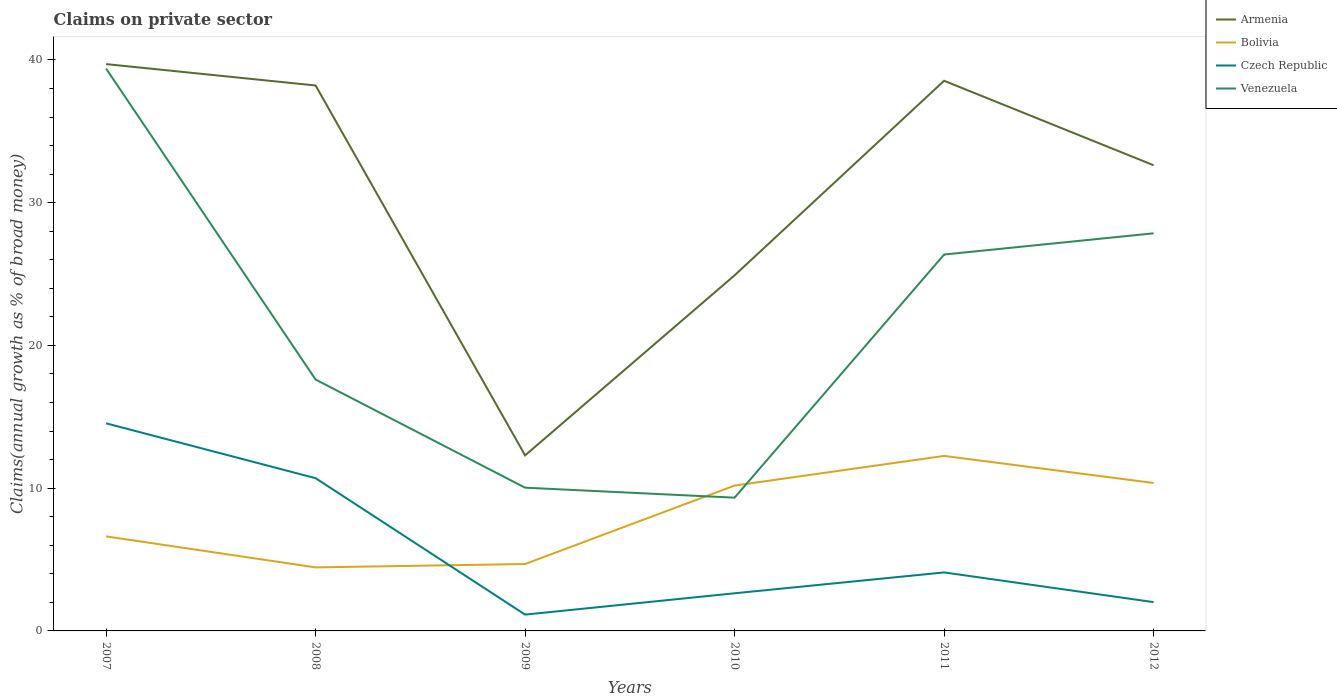Does the line corresponding to Armenia intersect with the line corresponding to Czech Republic?
Keep it short and to the point. No. Across all years, what is the maximum percentage of broad money claimed on private sector in Czech Republic?
Ensure brevity in your answer.  1.14. In which year was the percentage of broad money claimed on private sector in Czech Republic maximum?
Keep it short and to the point. 2009. What is the total percentage of broad money claimed on private sector in Armenia in the graph?
Provide a short and direct response. -7.71. What is the difference between the highest and the second highest percentage of broad money claimed on private sector in Bolivia?
Make the answer very short. 7.81. Are the values on the major ticks of Y-axis written in scientific E-notation?
Your answer should be very brief. No. Where does the legend appear in the graph?
Ensure brevity in your answer.  Top right. How many legend labels are there?
Your answer should be very brief. 4. How are the legend labels stacked?
Your answer should be very brief. Vertical. What is the title of the graph?
Offer a very short reply. Claims on private sector. What is the label or title of the X-axis?
Give a very brief answer. Years. What is the label or title of the Y-axis?
Provide a short and direct response. Claims(annual growth as % of broad money). What is the Claims(annual growth as % of broad money) of Armenia in 2007?
Your answer should be compact. 39.71. What is the Claims(annual growth as % of broad money) of Bolivia in 2007?
Ensure brevity in your answer.  6.62. What is the Claims(annual growth as % of broad money) in Czech Republic in 2007?
Give a very brief answer. 14.54. What is the Claims(annual growth as % of broad money) in Venezuela in 2007?
Keep it short and to the point. 39.39. What is the Claims(annual growth as % of broad money) of Armenia in 2008?
Your response must be concise. 38.21. What is the Claims(annual growth as % of broad money) in Bolivia in 2008?
Your response must be concise. 4.45. What is the Claims(annual growth as % of broad money) in Czech Republic in 2008?
Your answer should be very brief. 10.7. What is the Claims(annual growth as % of broad money) of Venezuela in 2008?
Provide a short and direct response. 17.61. What is the Claims(annual growth as % of broad money) of Armenia in 2009?
Give a very brief answer. 12.3. What is the Claims(annual growth as % of broad money) of Bolivia in 2009?
Give a very brief answer. 4.69. What is the Claims(annual growth as % of broad money) of Czech Republic in 2009?
Offer a terse response. 1.14. What is the Claims(annual growth as % of broad money) of Venezuela in 2009?
Make the answer very short. 10.03. What is the Claims(annual growth as % of broad money) in Armenia in 2010?
Offer a very short reply. 24.91. What is the Claims(annual growth as % of broad money) in Bolivia in 2010?
Give a very brief answer. 10.18. What is the Claims(annual growth as % of broad money) of Czech Republic in 2010?
Provide a short and direct response. 2.64. What is the Claims(annual growth as % of broad money) in Venezuela in 2010?
Ensure brevity in your answer.  9.33. What is the Claims(annual growth as % of broad money) of Armenia in 2011?
Keep it short and to the point. 38.54. What is the Claims(annual growth as % of broad money) in Bolivia in 2011?
Your answer should be very brief. 12.26. What is the Claims(annual growth as % of broad money) of Czech Republic in 2011?
Your answer should be compact. 4.1. What is the Claims(annual growth as % of broad money) of Venezuela in 2011?
Offer a very short reply. 26.37. What is the Claims(annual growth as % of broad money) in Armenia in 2012?
Give a very brief answer. 32.62. What is the Claims(annual growth as % of broad money) in Bolivia in 2012?
Your answer should be compact. 10.36. What is the Claims(annual growth as % of broad money) in Czech Republic in 2012?
Provide a succinct answer. 2.02. What is the Claims(annual growth as % of broad money) of Venezuela in 2012?
Your answer should be very brief. 27.85. Across all years, what is the maximum Claims(annual growth as % of broad money) of Armenia?
Offer a very short reply. 39.71. Across all years, what is the maximum Claims(annual growth as % of broad money) in Bolivia?
Ensure brevity in your answer.  12.26. Across all years, what is the maximum Claims(annual growth as % of broad money) in Czech Republic?
Ensure brevity in your answer.  14.54. Across all years, what is the maximum Claims(annual growth as % of broad money) of Venezuela?
Keep it short and to the point. 39.39. Across all years, what is the minimum Claims(annual growth as % of broad money) in Armenia?
Provide a succinct answer. 12.3. Across all years, what is the minimum Claims(annual growth as % of broad money) of Bolivia?
Make the answer very short. 4.45. Across all years, what is the minimum Claims(annual growth as % of broad money) in Czech Republic?
Your answer should be compact. 1.14. Across all years, what is the minimum Claims(annual growth as % of broad money) of Venezuela?
Ensure brevity in your answer.  9.33. What is the total Claims(annual growth as % of broad money) in Armenia in the graph?
Offer a terse response. 186.28. What is the total Claims(annual growth as % of broad money) of Bolivia in the graph?
Provide a succinct answer. 48.56. What is the total Claims(annual growth as % of broad money) in Czech Republic in the graph?
Keep it short and to the point. 35.14. What is the total Claims(annual growth as % of broad money) of Venezuela in the graph?
Give a very brief answer. 130.59. What is the difference between the Claims(annual growth as % of broad money) in Armenia in 2007 and that in 2008?
Offer a very short reply. 1.5. What is the difference between the Claims(annual growth as % of broad money) in Bolivia in 2007 and that in 2008?
Offer a very short reply. 2.17. What is the difference between the Claims(annual growth as % of broad money) of Czech Republic in 2007 and that in 2008?
Make the answer very short. 3.84. What is the difference between the Claims(annual growth as % of broad money) of Venezuela in 2007 and that in 2008?
Your answer should be compact. 21.78. What is the difference between the Claims(annual growth as % of broad money) in Armenia in 2007 and that in 2009?
Your answer should be very brief. 27.41. What is the difference between the Claims(annual growth as % of broad money) of Bolivia in 2007 and that in 2009?
Keep it short and to the point. 1.94. What is the difference between the Claims(annual growth as % of broad money) of Czech Republic in 2007 and that in 2009?
Your answer should be very brief. 13.4. What is the difference between the Claims(annual growth as % of broad money) in Venezuela in 2007 and that in 2009?
Offer a terse response. 29.36. What is the difference between the Claims(annual growth as % of broad money) in Armenia in 2007 and that in 2010?
Make the answer very short. 14.8. What is the difference between the Claims(annual growth as % of broad money) in Bolivia in 2007 and that in 2010?
Keep it short and to the point. -3.56. What is the difference between the Claims(annual growth as % of broad money) in Czech Republic in 2007 and that in 2010?
Provide a short and direct response. 11.91. What is the difference between the Claims(annual growth as % of broad money) in Venezuela in 2007 and that in 2010?
Provide a short and direct response. 30.06. What is the difference between the Claims(annual growth as % of broad money) in Armenia in 2007 and that in 2011?
Your response must be concise. 1.17. What is the difference between the Claims(annual growth as % of broad money) in Bolivia in 2007 and that in 2011?
Make the answer very short. -5.64. What is the difference between the Claims(annual growth as % of broad money) of Czech Republic in 2007 and that in 2011?
Your answer should be compact. 10.44. What is the difference between the Claims(annual growth as % of broad money) in Venezuela in 2007 and that in 2011?
Provide a short and direct response. 13.03. What is the difference between the Claims(annual growth as % of broad money) of Armenia in 2007 and that in 2012?
Your response must be concise. 7.09. What is the difference between the Claims(annual growth as % of broad money) in Bolivia in 2007 and that in 2012?
Provide a succinct answer. -3.74. What is the difference between the Claims(annual growth as % of broad money) in Czech Republic in 2007 and that in 2012?
Keep it short and to the point. 12.52. What is the difference between the Claims(annual growth as % of broad money) of Venezuela in 2007 and that in 2012?
Your answer should be very brief. 11.54. What is the difference between the Claims(annual growth as % of broad money) in Armenia in 2008 and that in 2009?
Make the answer very short. 25.91. What is the difference between the Claims(annual growth as % of broad money) of Bolivia in 2008 and that in 2009?
Offer a very short reply. -0.24. What is the difference between the Claims(annual growth as % of broad money) of Czech Republic in 2008 and that in 2009?
Ensure brevity in your answer.  9.56. What is the difference between the Claims(annual growth as % of broad money) in Venezuela in 2008 and that in 2009?
Your answer should be compact. 7.58. What is the difference between the Claims(annual growth as % of broad money) of Armenia in 2008 and that in 2010?
Keep it short and to the point. 13.3. What is the difference between the Claims(annual growth as % of broad money) in Bolivia in 2008 and that in 2010?
Your answer should be very brief. -5.73. What is the difference between the Claims(annual growth as % of broad money) of Czech Republic in 2008 and that in 2010?
Provide a short and direct response. 8.06. What is the difference between the Claims(annual growth as % of broad money) of Venezuela in 2008 and that in 2010?
Ensure brevity in your answer.  8.27. What is the difference between the Claims(annual growth as % of broad money) in Armenia in 2008 and that in 2011?
Your answer should be compact. -0.33. What is the difference between the Claims(annual growth as % of broad money) of Bolivia in 2008 and that in 2011?
Your answer should be compact. -7.81. What is the difference between the Claims(annual growth as % of broad money) of Czech Republic in 2008 and that in 2011?
Your answer should be compact. 6.6. What is the difference between the Claims(annual growth as % of broad money) in Venezuela in 2008 and that in 2011?
Provide a succinct answer. -8.76. What is the difference between the Claims(annual growth as % of broad money) of Armenia in 2008 and that in 2012?
Your answer should be very brief. 5.59. What is the difference between the Claims(annual growth as % of broad money) of Bolivia in 2008 and that in 2012?
Your answer should be compact. -5.91. What is the difference between the Claims(annual growth as % of broad money) of Czech Republic in 2008 and that in 2012?
Keep it short and to the point. 8.68. What is the difference between the Claims(annual growth as % of broad money) of Venezuela in 2008 and that in 2012?
Make the answer very short. -10.24. What is the difference between the Claims(annual growth as % of broad money) of Armenia in 2009 and that in 2010?
Make the answer very short. -12.61. What is the difference between the Claims(annual growth as % of broad money) in Bolivia in 2009 and that in 2010?
Your response must be concise. -5.5. What is the difference between the Claims(annual growth as % of broad money) of Czech Republic in 2009 and that in 2010?
Offer a terse response. -1.49. What is the difference between the Claims(annual growth as % of broad money) of Venezuela in 2009 and that in 2010?
Your answer should be very brief. 0.7. What is the difference between the Claims(annual growth as % of broad money) of Armenia in 2009 and that in 2011?
Give a very brief answer. -26.24. What is the difference between the Claims(annual growth as % of broad money) in Bolivia in 2009 and that in 2011?
Your answer should be compact. -7.57. What is the difference between the Claims(annual growth as % of broad money) in Czech Republic in 2009 and that in 2011?
Your response must be concise. -2.95. What is the difference between the Claims(annual growth as % of broad money) of Venezuela in 2009 and that in 2011?
Offer a very short reply. -16.33. What is the difference between the Claims(annual growth as % of broad money) of Armenia in 2009 and that in 2012?
Your response must be concise. -20.32. What is the difference between the Claims(annual growth as % of broad money) of Bolivia in 2009 and that in 2012?
Provide a short and direct response. -5.68. What is the difference between the Claims(annual growth as % of broad money) of Czech Republic in 2009 and that in 2012?
Make the answer very short. -0.88. What is the difference between the Claims(annual growth as % of broad money) in Venezuela in 2009 and that in 2012?
Give a very brief answer. -17.82. What is the difference between the Claims(annual growth as % of broad money) in Armenia in 2010 and that in 2011?
Make the answer very short. -13.63. What is the difference between the Claims(annual growth as % of broad money) in Bolivia in 2010 and that in 2011?
Provide a succinct answer. -2.08. What is the difference between the Claims(annual growth as % of broad money) of Czech Republic in 2010 and that in 2011?
Your response must be concise. -1.46. What is the difference between the Claims(annual growth as % of broad money) of Venezuela in 2010 and that in 2011?
Provide a short and direct response. -17.03. What is the difference between the Claims(annual growth as % of broad money) of Armenia in 2010 and that in 2012?
Keep it short and to the point. -7.71. What is the difference between the Claims(annual growth as % of broad money) of Bolivia in 2010 and that in 2012?
Provide a succinct answer. -0.18. What is the difference between the Claims(annual growth as % of broad money) of Czech Republic in 2010 and that in 2012?
Give a very brief answer. 0.62. What is the difference between the Claims(annual growth as % of broad money) in Venezuela in 2010 and that in 2012?
Provide a short and direct response. -18.52. What is the difference between the Claims(annual growth as % of broad money) in Armenia in 2011 and that in 2012?
Offer a very short reply. 5.92. What is the difference between the Claims(annual growth as % of broad money) of Bolivia in 2011 and that in 2012?
Make the answer very short. 1.9. What is the difference between the Claims(annual growth as % of broad money) of Czech Republic in 2011 and that in 2012?
Provide a succinct answer. 2.08. What is the difference between the Claims(annual growth as % of broad money) in Venezuela in 2011 and that in 2012?
Your answer should be very brief. -1.49. What is the difference between the Claims(annual growth as % of broad money) of Armenia in 2007 and the Claims(annual growth as % of broad money) of Bolivia in 2008?
Your response must be concise. 35.26. What is the difference between the Claims(annual growth as % of broad money) of Armenia in 2007 and the Claims(annual growth as % of broad money) of Czech Republic in 2008?
Keep it short and to the point. 29.01. What is the difference between the Claims(annual growth as % of broad money) in Armenia in 2007 and the Claims(annual growth as % of broad money) in Venezuela in 2008?
Offer a very short reply. 22.1. What is the difference between the Claims(annual growth as % of broad money) of Bolivia in 2007 and the Claims(annual growth as % of broad money) of Czech Republic in 2008?
Give a very brief answer. -4.08. What is the difference between the Claims(annual growth as % of broad money) in Bolivia in 2007 and the Claims(annual growth as % of broad money) in Venezuela in 2008?
Make the answer very short. -10.99. What is the difference between the Claims(annual growth as % of broad money) in Czech Republic in 2007 and the Claims(annual growth as % of broad money) in Venezuela in 2008?
Your response must be concise. -3.07. What is the difference between the Claims(annual growth as % of broad money) in Armenia in 2007 and the Claims(annual growth as % of broad money) in Bolivia in 2009?
Provide a short and direct response. 35.02. What is the difference between the Claims(annual growth as % of broad money) of Armenia in 2007 and the Claims(annual growth as % of broad money) of Czech Republic in 2009?
Make the answer very short. 38.56. What is the difference between the Claims(annual growth as % of broad money) of Armenia in 2007 and the Claims(annual growth as % of broad money) of Venezuela in 2009?
Provide a short and direct response. 29.67. What is the difference between the Claims(annual growth as % of broad money) of Bolivia in 2007 and the Claims(annual growth as % of broad money) of Czech Republic in 2009?
Keep it short and to the point. 5.48. What is the difference between the Claims(annual growth as % of broad money) in Bolivia in 2007 and the Claims(annual growth as % of broad money) in Venezuela in 2009?
Keep it short and to the point. -3.41. What is the difference between the Claims(annual growth as % of broad money) of Czech Republic in 2007 and the Claims(annual growth as % of broad money) of Venezuela in 2009?
Your answer should be very brief. 4.51. What is the difference between the Claims(annual growth as % of broad money) in Armenia in 2007 and the Claims(annual growth as % of broad money) in Bolivia in 2010?
Give a very brief answer. 29.52. What is the difference between the Claims(annual growth as % of broad money) in Armenia in 2007 and the Claims(annual growth as % of broad money) in Czech Republic in 2010?
Your answer should be very brief. 37.07. What is the difference between the Claims(annual growth as % of broad money) of Armenia in 2007 and the Claims(annual growth as % of broad money) of Venezuela in 2010?
Your answer should be very brief. 30.37. What is the difference between the Claims(annual growth as % of broad money) in Bolivia in 2007 and the Claims(annual growth as % of broad money) in Czech Republic in 2010?
Ensure brevity in your answer.  3.99. What is the difference between the Claims(annual growth as % of broad money) in Bolivia in 2007 and the Claims(annual growth as % of broad money) in Venezuela in 2010?
Keep it short and to the point. -2.71. What is the difference between the Claims(annual growth as % of broad money) of Czech Republic in 2007 and the Claims(annual growth as % of broad money) of Venezuela in 2010?
Offer a terse response. 5.21. What is the difference between the Claims(annual growth as % of broad money) in Armenia in 2007 and the Claims(annual growth as % of broad money) in Bolivia in 2011?
Your answer should be very brief. 27.45. What is the difference between the Claims(annual growth as % of broad money) in Armenia in 2007 and the Claims(annual growth as % of broad money) in Czech Republic in 2011?
Give a very brief answer. 35.61. What is the difference between the Claims(annual growth as % of broad money) of Armenia in 2007 and the Claims(annual growth as % of broad money) of Venezuela in 2011?
Make the answer very short. 13.34. What is the difference between the Claims(annual growth as % of broad money) of Bolivia in 2007 and the Claims(annual growth as % of broad money) of Czech Republic in 2011?
Your answer should be compact. 2.53. What is the difference between the Claims(annual growth as % of broad money) in Bolivia in 2007 and the Claims(annual growth as % of broad money) in Venezuela in 2011?
Provide a short and direct response. -19.74. What is the difference between the Claims(annual growth as % of broad money) in Czech Republic in 2007 and the Claims(annual growth as % of broad money) in Venezuela in 2011?
Make the answer very short. -11.82. What is the difference between the Claims(annual growth as % of broad money) of Armenia in 2007 and the Claims(annual growth as % of broad money) of Bolivia in 2012?
Give a very brief answer. 29.34. What is the difference between the Claims(annual growth as % of broad money) of Armenia in 2007 and the Claims(annual growth as % of broad money) of Czech Republic in 2012?
Offer a terse response. 37.69. What is the difference between the Claims(annual growth as % of broad money) in Armenia in 2007 and the Claims(annual growth as % of broad money) in Venezuela in 2012?
Make the answer very short. 11.85. What is the difference between the Claims(annual growth as % of broad money) in Bolivia in 2007 and the Claims(annual growth as % of broad money) in Czech Republic in 2012?
Give a very brief answer. 4.6. What is the difference between the Claims(annual growth as % of broad money) in Bolivia in 2007 and the Claims(annual growth as % of broad money) in Venezuela in 2012?
Keep it short and to the point. -21.23. What is the difference between the Claims(annual growth as % of broad money) of Czech Republic in 2007 and the Claims(annual growth as % of broad money) of Venezuela in 2012?
Keep it short and to the point. -13.31. What is the difference between the Claims(annual growth as % of broad money) in Armenia in 2008 and the Claims(annual growth as % of broad money) in Bolivia in 2009?
Provide a succinct answer. 33.52. What is the difference between the Claims(annual growth as % of broad money) in Armenia in 2008 and the Claims(annual growth as % of broad money) in Czech Republic in 2009?
Make the answer very short. 37.07. What is the difference between the Claims(annual growth as % of broad money) of Armenia in 2008 and the Claims(annual growth as % of broad money) of Venezuela in 2009?
Provide a succinct answer. 28.18. What is the difference between the Claims(annual growth as % of broad money) of Bolivia in 2008 and the Claims(annual growth as % of broad money) of Czech Republic in 2009?
Make the answer very short. 3.31. What is the difference between the Claims(annual growth as % of broad money) in Bolivia in 2008 and the Claims(annual growth as % of broad money) in Venezuela in 2009?
Your response must be concise. -5.58. What is the difference between the Claims(annual growth as % of broad money) of Czech Republic in 2008 and the Claims(annual growth as % of broad money) of Venezuela in 2009?
Your answer should be very brief. 0.67. What is the difference between the Claims(annual growth as % of broad money) in Armenia in 2008 and the Claims(annual growth as % of broad money) in Bolivia in 2010?
Your answer should be compact. 28.03. What is the difference between the Claims(annual growth as % of broad money) of Armenia in 2008 and the Claims(annual growth as % of broad money) of Czech Republic in 2010?
Your answer should be compact. 35.57. What is the difference between the Claims(annual growth as % of broad money) of Armenia in 2008 and the Claims(annual growth as % of broad money) of Venezuela in 2010?
Give a very brief answer. 28.87. What is the difference between the Claims(annual growth as % of broad money) of Bolivia in 2008 and the Claims(annual growth as % of broad money) of Czech Republic in 2010?
Offer a very short reply. 1.81. What is the difference between the Claims(annual growth as % of broad money) of Bolivia in 2008 and the Claims(annual growth as % of broad money) of Venezuela in 2010?
Provide a short and direct response. -4.88. What is the difference between the Claims(annual growth as % of broad money) of Czech Republic in 2008 and the Claims(annual growth as % of broad money) of Venezuela in 2010?
Offer a terse response. 1.37. What is the difference between the Claims(annual growth as % of broad money) of Armenia in 2008 and the Claims(annual growth as % of broad money) of Bolivia in 2011?
Provide a short and direct response. 25.95. What is the difference between the Claims(annual growth as % of broad money) in Armenia in 2008 and the Claims(annual growth as % of broad money) in Czech Republic in 2011?
Give a very brief answer. 34.11. What is the difference between the Claims(annual growth as % of broad money) of Armenia in 2008 and the Claims(annual growth as % of broad money) of Venezuela in 2011?
Provide a succinct answer. 11.84. What is the difference between the Claims(annual growth as % of broad money) in Bolivia in 2008 and the Claims(annual growth as % of broad money) in Czech Republic in 2011?
Provide a short and direct response. 0.35. What is the difference between the Claims(annual growth as % of broad money) in Bolivia in 2008 and the Claims(annual growth as % of broad money) in Venezuela in 2011?
Keep it short and to the point. -21.92. What is the difference between the Claims(annual growth as % of broad money) in Czech Republic in 2008 and the Claims(annual growth as % of broad money) in Venezuela in 2011?
Provide a succinct answer. -15.67. What is the difference between the Claims(annual growth as % of broad money) of Armenia in 2008 and the Claims(annual growth as % of broad money) of Bolivia in 2012?
Give a very brief answer. 27.85. What is the difference between the Claims(annual growth as % of broad money) in Armenia in 2008 and the Claims(annual growth as % of broad money) in Czech Republic in 2012?
Provide a succinct answer. 36.19. What is the difference between the Claims(annual growth as % of broad money) in Armenia in 2008 and the Claims(annual growth as % of broad money) in Venezuela in 2012?
Ensure brevity in your answer.  10.36. What is the difference between the Claims(annual growth as % of broad money) of Bolivia in 2008 and the Claims(annual growth as % of broad money) of Czech Republic in 2012?
Keep it short and to the point. 2.43. What is the difference between the Claims(annual growth as % of broad money) in Bolivia in 2008 and the Claims(annual growth as % of broad money) in Venezuela in 2012?
Offer a terse response. -23.4. What is the difference between the Claims(annual growth as % of broad money) of Czech Republic in 2008 and the Claims(annual growth as % of broad money) of Venezuela in 2012?
Ensure brevity in your answer.  -17.15. What is the difference between the Claims(annual growth as % of broad money) in Armenia in 2009 and the Claims(annual growth as % of broad money) in Bolivia in 2010?
Provide a succinct answer. 2.11. What is the difference between the Claims(annual growth as % of broad money) in Armenia in 2009 and the Claims(annual growth as % of broad money) in Czech Republic in 2010?
Make the answer very short. 9.66. What is the difference between the Claims(annual growth as % of broad money) in Armenia in 2009 and the Claims(annual growth as % of broad money) in Venezuela in 2010?
Ensure brevity in your answer.  2.96. What is the difference between the Claims(annual growth as % of broad money) in Bolivia in 2009 and the Claims(annual growth as % of broad money) in Czech Republic in 2010?
Your answer should be very brief. 2.05. What is the difference between the Claims(annual growth as % of broad money) in Bolivia in 2009 and the Claims(annual growth as % of broad money) in Venezuela in 2010?
Give a very brief answer. -4.65. What is the difference between the Claims(annual growth as % of broad money) in Czech Republic in 2009 and the Claims(annual growth as % of broad money) in Venezuela in 2010?
Provide a short and direct response. -8.19. What is the difference between the Claims(annual growth as % of broad money) in Armenia in 2009 and the Claims(annual growth as % of broad money) in Bolivia in 2011?
Give a very brief answer. 0.04. What is the difference between the Claims(annual growth as % of broad money) of Armenia in 2009 and the Claims(annual growth as % of broad money) of Czech Republic in 2011?
Your response must be concise. 8.2. What is the difference between the Claims(annual growth as % of broad money) in Armenia in 2009 and the Claims(annual growth as % of broad money) in Venezuela in 2011?
Make the answer very short. -14.07. What is the difference between the Claims(annual growth as % of broad money) of Bolivia in 2009 and the Claims(annual growth as % of broad money) of Czech Republic in 2011?
Ensure brevity in your answer.  0.59. What is the difference between the Claims(annual growth as % of broad money) of Bolivia in 2009 and the Claims(annual growth as % of broad money) of Venezuela in 2011?
Give a very brief answer. -21.68. What is the difference between the Claims(annual growth as % of broad money) in Czech Republic in 2009 and the Claims(annual growth as % of broad money) in Venezuela in 2011?
Provide a short and direct response. -25.22. What is the difference between the Claims(annual growth as % of broad money) in Armenia in 2009 and the Claims(annual growth as % of broad money) in Bolivia in 2012?
Your response must be concise. 1.93. What is the difference between the Claims(annual growth as % of broad money) in Armenia in 2009 and the Claims(annual growth as % of broad money) in Czech Republic in 2012?
Your answer should be very brief. 10.28. What is the difference between the Claims(annual growth as % of broad money) of Armenia in 2009 and the Claims(annual growth as % of broad money) of Venezuela in 2012?
Provide a short and direct response. -15.56. What is the difference between the Claims(annual growth as % of broad money) in Bolivia in 2009 and the Claims(annual growth as % of broad money) in Czech Republic in 2012?
Provide a short and direct response. 2.67. What is the difference between the Claims(annual growth as % of broad money) in Bolivia in 2009 and the Claims(annual growth as % of broad money) in Venezuela in 2012?
Give a very brief answer. -23.17. What is the difference between the Claims(annual growth as % of broad money) of Czech Republic in 2009 and the Claims(annual growth as % of broad money) of Venezuela in 2012?
Provide a succinct answer. -26.71. What is the difference between the Claims(annual growth as % of broad money) in Armenia in 2010 and the Claims(annual growth as % of broad money) in Bolivia in 2011?
Give a very brief answer. 12.65. What is the difference between the Claims(annual growth as % of broad money) in Armenia in 2010 and the Claims(annual growth as % of broad money) in Czech Republic in 2011?
Your answer should be very brief. 20.81. What is the difference between the Claims(annual growth as % of broad money) of Armenia in 2010 and the Claims(annual growth as % of broad money) of Venezuela in 2011?
Offer a terse response. -1.46. What is the difference between the Claims(annual growth as % of broad money) in Bolivia in 2010 and the Claims(annual growth as % of broad money) in Czech Republic in 2011?
Give a very brief answer. 6.08. What is the difference between the Claims(annual growth as % of broad money) in Bolivia in 2010 and the Claims(annual growth as % of broad money) in Venezuela in 2011?
Keep it short and to the point. -16.18. What is the difference between the Claims(annual growth as % of broad money) in Czech Republic in 2010 and the Claims(annual growth as % of broad money) in Venezuela in 2011?
Provide a succinct answer. -23.73. What is the difference between the Claims(annual growth as % of broad money) of Armenia in 2010 and the Claims(annual growth as % of broad money) of Bolivia in 2012?
Give a very brief answer. 14.55. What is the difference between the Claims(annual growth as % of broad money) in Armenia in 2010 and the Claims(annual growth as % of broad money) in Czech Republic in 2012?
Provide a succinct answer. 22.89. What is the difference between the Claims(annual growth as % of broad money) of Armenia in 2010 and the Claims(annual growth as % of broad money) of Venezuela in 2012?
Your response must be concise. -2.94. What is the difference between the Claims(annual growth as % of broad money) of Bolivia in 2010 and the Claims(annual growth as % of broad money) of Czech Republic in 2012?
Ensure brevity in your answer.  8.16. What is the difference between the Claims(annual growth as % of broad money) in Bolivia in 2010 and the Claims(annual growth as % of broad money) in Venezuela in 2012?
Offer a very short reply. -17.67. What is the difference between the Claims(annual growth as % of broad money) in Czech Republic in 2010 and the Claims(annual growth as % of broad money) in Venezuela in 2012?
Offer a terse response. -25.22. What is the difference between the Claims(annual growth as % of broad money) in Armenia in 2011 and the Claims(annual growth as % of broad money) in Bolivia in 2012?
Ensure brevity in your answer.  28.18. What is the difference between the Claims(annual growth as % of broad money) in Armenia in 2011 and the Claims(annual growth as % of broad money) in Czech Republic in 2012?
Ensure brevity in your answer.  36.52. What is the difference between the Claims(annual growth as % of broad money) in Armenia in 2011 and the Claims(annual growth as % of broad money) in Venezuela in 2012?
Make the answer very short. 10.69. What is the difference between the Claims(annual growth as % of broad money) of Bolivia in 2011 and the Claims(annual growth as % of broad money) of Czech Republic in 2012?
Your answer should be compact. 10.24. What is the difference between the Claims(annual growth as % of broad money) in Bolivia in 2011 and the Claims(annual growth as % of broad money) in Venezuela in 2012?
Your answer should be very brief. -15.59. What is the difference between the Claims(annual growth as % of broad money) in Czech Republic in 2011 and the Claims(annual growth as % of broad money) in Venezuela in 2012?
Your answer should be compact. -23.75. What is the average Claims(annual growth as % of broad money) in Armenia per year?
Provide a succinct answer. 31.05. What is the average Claims(annual growth as % of broad money) in Bolivia per year?
Your answer should be very brief. 8.09. What is the average Claims(annual growth as % of broad money) in Czech Republic per year?
Offer a very short reply. 5.86. What is the average Claims(annual growth as % of broad money) of Venezuela per year?
Your answer should be very brief. 21.77. In the year 2007, what is the difference between the Claims(annual growth as % of broad money) of Armenia and Claims(annual growth as % of broad money) of Bolivia?
Offer a terse response. 33.08. In the year 2007, what is the difference between the Claims(annual growth as % of broad money) of Armenia and Claims(annual growth as % of broad money) of Czech Republic?
Your answer should be very brief. 25.16. In the year 2007, what is the difference between the Claims(annual growth as % of broad money) of Armenia and Claims(annual growth as % of broad money) of Venezuela?
Provide a succinct answer. 0.31. In the year 2007, what is the difference between the Claims(annual growth as % of broad money) of Bolivia and Claims(annual growth as % of broad money) of Czech Republic?
Offer a terse response. -7.92. In the year 2007, what is the difference between the Claims(annual growth as % of broad money) of Bolivia and Claims(annual growth as % of broad money) of Venezuela?
Ensure brevity in your answer.  -32.77. In the year 2007, what is the difference between the Claims(annual growth as % of broad money) of Czech Republic and Claims(annual growth as % of broad money) of Venezuela?
Provide a short and direct response. -24.85. In the year 2008, what is the difference between the Claims(annual growth as % of broad money) in Armenia and Claims(annual growth as % of broad money) in Bolivia?
Your answer should be compact. 33.76. In the year 2008, what is the difference between the Claims(annual growth as % of broad money) in Armenia and Claims(annual growth as % of broad money) in Czech Republic?
Offer a terse response. 27.51. In the year 2008, what is the difference between the Claims(annual growth as % of broad money) in Armenia and Claims(annual growth as % of broad money) in Venezuela?
Offer a terse response. 20.6. In the year 2008, what is the difference between the Claims(annual growth as % of broad money) of Bolivia and Claims(annual growth as % of broad money) of Czech Republic?
Make the answer very short. -6.25. In the year 2008, what is the difference between the Claims(annual growth as % of broad money) of Bolivia and Claims(annual growth as % of broad money) of Venezuela?
Offer a terse response. -13.16. In the year 2008, what is the difference between the Claims(annual growth as % of broad money) of Czech Republic and Claims(annual growth as % of broad money) of Venezuela?
Keep it short and to the point. -6.91. In the year 2009, what is the difference between the Claims(annual growth as % of broad money) in Armenia and Claims(annual growth as % of broad money) in Bolivia?
Keep it short and to the point. 7.61. In the year 2009, what is the difference between the Claims(annual growth as % of broad money) in Armenia and Claims(annual growth as % of broad money) in Czech Republic?
Keep it short and to the point. 11.15. In the year 2009, what is the difference between the Claims(annual growth as % of broad money) in Armenia and Claims(annual growth as % of broad money) in Venezuela?
Your response must be concise. 2.26. In the year 2009, what is the difference between the Claims(annual growth as % of broad money) in Bolivia and Claims(annual growth as % of broad money) in Czech Republic?
Your response must be concise. 3.54. In the year 2009, what is the difference between the Claims(annual growth as % of broad money) of Bolivia and Claims(annual growth as % of broad money) of Venezuela?
Provide a succinct answer. -5.35. In the year 2009, what is the difference between the Claims(annual growth as % of broad money) of Czech Republic and Claims(annual growth as % of broad money) of Venezuela?
Your response must be concise. -8.89. In the year 2010, what is the difference between the Claims(annual growth as % of broad money) of Armenia and Claims(annual growth as % of broad money) of Bolivia?
Ensure brevity in your answer.  14.73. In the year 2010, what is the difference between the Claims(annual growth as % of broad money) of Armenia and Claims(annual growth as % of broad money) of Czech Republic?
Your response must be concise. 22.27. In the year 2010, what is the difference between the Claims(annual growth as % of broad money) of Armenia and Claims(annual growth as % of broad money) of Venezuela?
Provide a short and direct response. 15.57. In the year 2010, what is the difference between the Claims(annual growth as % of broad money) of Bolivia and Claims(annual growth as % of broad money) of Czech Republic?
Make the answer very short. 7.55. In the year 2010, what is the difference between the Claims(annual growth as % of broad money) of Bolivia and Claims(annual growth as % of broad money) of Venezuela?
Offer a terse response. 0.85. In the year 2010, what is the difference between the Claims(annual growth as % of broad money) in Czech Republic and Claims(annual growth as % of broad money) in Venezuela?
Keep it short and to the point. -6.7. In the year 2011, what is the difference between the Claims(annual growth as % of broad money) in Armenia and Claims(annual growth as % of broad money) in Bolivia?
Your answer should be very brief. 26.28. In the year 2011, what is the difference between the Claims(annual growth as % of broad money) in Armenia and Claims(annual growth as % of broad money) in Czech Republic?
Offer a very short reply. 34.44. In the year 2011, what is the difference between the Claims(annual growth as % of broad money) in Armenia and Claims(annual growth as % of broad money) in Venezuela?
Provide a succinct answer. 12.17. In the year 2011, what is the difference between the Claims(annual growth as % of broad money) of Bolivia and Claims(annual growth as % of broad money) of Czech Republic?
Give a very brief answer. 8.16. In the year 2011, what is the difference between the Claims(annual growth as % of broad money) in Bolivia and Claims(annual growth as % of broad money) in Venezuela?
Offer a very short reply. -14.11. In the year 2011, what is the difference between the Claims(annual growth as % of broad money) in Czech Republic and Claims(annual growth as % of broad money) in Venezuela?
Give a very brief answer. -22.27. In the year 2012, what is the difference between the Claims(annual growth as % of broad money) in Armenia and Claims(annual growth as % of broad money) in Bolivia?
Your answer should be very brief. 22.26. In the year 2012, what is the difference between the Claims(annual growth as % of broad money) of Armenia and Claims(annual growth as % of broad money) of Czech Republic?
Make the answer very short. 30.6. In the year 2012, what is the difference between the Claims(annual growth as % of broad money) of Armenia and Claims(annual growth as % of broad money) of Venezuela?
Provide a short and direct response. 4.77. In the year 2012, what is the difference between the Claims(annual growth as % of broad money) in Bolivia and Claims(annual growth as % of broad money) in Czech Republic?
Ensure brevity in your answer.  8.34. In the year 2012, what is the difference between the Claims(annual growth as % of broad money) of Bolivia and Claims(annual growth as % of broad money) of Venezuela?
Your response must be concise. -17.49. In the year 2012, what is the difference between the Claims(annual growth as % of broad money) in Czech Republic and Claims(annual growth as % of broad money) in Venezuela?
Offer a very short reply. -25.83. What is the ratio of the Claims(annual growth as % of broad money) of Armenia in 2007 to that in 2008?
Give a very brief answer. 1.04. What is the ratio of the Claims(annual growth as % of broad money) of Bolivia in 2007 to that in 2008?
Give a very brief answer. 1.49. What is the ratio of the Claims(annual growth as % of broad money) in Czech Republic in 2007 to that in 2008?
Your answer should be very brief. 1.36. What is the ratio of the Claims(annual growth as % of broad money) of Venezuela in 2007 to that in 2008?
Make the answer very short. 2.24. What is the ratio of the Claims(annual growth as % of broad money) of Armenia in 2007 to that in 2009?
Your answer should be compact. 3.23. What is the ratio of the Claims(annual growth as % of broad money) in Bolivia in 2007 to that in 2009?
Give a very brief answer. 1.41. What is the ratio of the Claims(annual growth as % of broad money) of Czech Republic in 2007 to that in 2009?
Offer a terse response. 12.72. What is the ratio of the Claims(annual growth as % of broad money) in Venezuela in 2007 to that in 2009?
Ensure brevity in your answer.  3.93. What is the ratio of the Claims(annual growth as % of broad money) of Armenia in 2007 to that in 2010?
Your answer should be very brief. 1.59. What is the ratio of the Claims(annual growth as % of broad money) in Bolivia in 2007 to that in 2010?
Provide a short and direct response. 0.65. What is the ratio of the Claims(annual growth as % of broad money) in Czech Republic in 2007 to that in 2010?
Give a very brief answer. 5.52. What is the ratio of the Claims(annual growth as % of broad money) of Venezuela in 2007 to that in 2010?
Your response must be concise. 4.22. What is the ratio of the Claims(annual growth as % of broad money) of Armenia in 2007 to that in 2011?
Offer a terse response. 1.03. What is the ratio of the Claims(annual growth as % of broad money) of Bolivia in 2007 to that in 2011?
Provide a short and direct response. 0.54. What is the ratio of the Claims(annual growth as % of broad money) in Czech Republic in 2007 to that in 2011?
Offer a terse response. 3.55. What is the ratio of the Claims(annual growth as % of broad money) of Venezuela in 2007 to that in 2011?
Ensure brevity in your answer.  1.49. What is the ratio of the Claims(annual growth as % of broad money) in Armenia in 2007 to that in 2012?
Offer a terse response. 1.22. What is the ratio of the Claims(annual growth as % of broad money) in Bolivia in 2007 to that in 2012?
Provide a short and direct response. 0.64. What is the ratio of the Claims(annual growth as % of broad money) of Czech Republic in 2007 to that in 2012?
Ensure brevity in your answer.  7.21. What is the ratio of the Claims(annual growth as % of broad money) of Venezuela in 2007 to that in 2012?
Provide a succinct answer. 1.41. What is the ratio of the Claims(annual growth as % of broad money) in Armenia in 2008 to that in 2009?
Provide a short and direct response. 3.11. What is the ratio of the Claims(annual growth as % of broad money) in Bolivia in 2008 to that in 2009?
Your answer should be very brief. 0.95. What is the ratio of the Claims(annual growth as % of broad money) of Czech Republic in 2008 to that in 2009?
Offer a terse response. 9.36. What is the ratio of the Claims(annual growth as % of broad money) of Venezuela in 2008 to that in 2009?
Offer a terse response. 1.75. What is the ratio of the Claims(annual growth as % of broad money) in Armenia in 2008 to that in 2010?
Your answer should be compact. 1.53. What is the ratio of the Claims(annual growth as % of broad money) of Bolivia in 2008 to that in 2010?
Keep it short and to the point. 0.44. What is the ratio of the Claims(annual growth as % of broad money) of Czech Republic in 2008 to that in 2010?
Ensure brevity in your answer.  4.06. What is the ratio of the Claims(annual growth as % of broad money) of Venezuela in 2008 to that in 2010?
Your answer should be compact. 1.89. What is the ratio of the Claims(annual growth as % of broad money) of Armenia in 2008 to that in 2011?
Provide a succinct answer. 0.99. What is the ratio of the Claims(annual growth as % of broad money) in Bolivia in 2008 to that in 2011?
Offer a very short reply. 0.36. What is the ratio of the Claims(annual growth as % of broad money) of Czech Republic in 2008 to that in 2011?
Your answer should be compact. 2.61. What is the ratio of the Claims(annual growth as % of broad money) of Venezuela in 2008 to that in 2011?
Make the answer very short. 0.67. What is the ratio of the Claims(annual growth as % of broad money) in Armenia in 2008 to that in 2012?
Provide a succinct answer. 1.17. What is the ratio of the Claims(annual growth as % of broad money) in Bolivia in 2008 to that in 2012?
Provide a succinct answer. 0.43. What is the ratio of the Claims(annual growth as % of broad money) in Czech Republic in 2008 to that in 2012?
Make the answer very short. 5.3. What is the ratio of the Claims(annual growth as % of broad money) in Venezuela in 2008 to that in 2012?
Your answer should be very brief. 0.63. What is the ratio of the Claims(annual growth as % of broad money) of Armenia in 2009 to that in 2010?
Make the answer very short. 0.49. What is the ratio of the Claims(annual growth as % of broad money) in Bolivia in 2009 to that in 2010?
Keep it short and to the point. 0.46. What is the ratio of the Claims(annual growth as % of broad money) of Czech Republic in 2009 to that in 2010?
Offer a terse response. 0.43. What is the ratio of the Claims(annual growth as % of broad money) of Venezuela in 2009 to that in 2010?
Ensure brevity in your answer.  1.07. What is the ratio of the Claims(annual growth as % of broad money) of Armenia in 2009 to that in 2011?
Your answer should be very brief. 0.32. What is the ratio of the Claims(annual growth as % of broad money) in Bolivia in 2009 to that in 2011?
Your answer should be very brief. 0.38. What is the ratio of the Claims(annual growth as % of broad money) in Czech Republic in 2009 to that in 2011?
Offer a very short reply. 0.28. What is the ratio of the Claims(annual growth as % of broad money) of Venezuela in 2009 to that in 2011?
Your answer should be compact. 0.38. What is the ratio of the Claims(annual growth as % of broad money) of Armenia in 2009 to that in 2012?
Give a very brief answer. 0.38. What is the ratio of the Claims(annual growth as % of broad money) of Bolivia in 2009 to that in 2012?
Provide a succinct answer. 0.45. What is the ratio of the Claims(annual growth as % of broad money) in Czech Republic in 2009 to that in 2012?
Your response must be concise. 0.57. What is the ratio of the Claims(annual growth as % of broad money) in Venezuela in 2009 to that in 2012?
Keep it short and to the point. 0.36. What is the ratio of the Claims(annual growth as % of broad money) in Armenia in 2010 to that in 2011?
Provide a short and direct response. 0.65. What is the ratio of the Claims(annual growth as % of broad money) in Bolivia in 2010 to that in 2011?
Ensure brevity in your answer.  0.83. What is the ratio of the Claims(annual growth as % of broad money) in Czech Republic in 2010 to that in 2011?
Provide a short and direct response. 0.64. What is the ratio of the Claims(annual growth as % of broad money) of Venezuela in 2010 to that in 2011?
Keep it short and to the point. 0.35. What is the ratio of the Claims(annual growth as % of broad money) of Armenia in 2010 to that in 2012?
Your answer should be compact. 0.76. What is the ratio of the Claims(annual growth as % of broad money) of Bolivia in 2010 to that in 2012?
Your response must be concise. 0.98. What is the ratio of the Claims(annual growth as % of broad money) of Czech Republic in 2010 to that in 2012?
Give a very brief answer. 1.31. What is the ratio of the Claims(annual growth as % of broad money) of Venezuela in 2010 to that in 2012?
Give a very brief answer. 0.34. What is the ratio of the Claims(annual growth as % of broad money) of Armenia in 2011 to that in 2012?
Your answer should be compact. 1.18. What is the ratio of the Claims(annual growth as % of broad money) of Bolivia in 2011 to that in 2012?
Offer a very short reply. 1.18. What is the ratio of the Claims(annual growth as % of broad money) of Czech Republic in 2011 to that in 2012?
Offer a very short reply. 2.03. What is the ratio of the Claims(annual growth as % of broad money) in Venezuela in 2011 to that in 2012?
Provide a short and direct response. 0.95. What is the difference between the highest and the second highest Claims(annual growth as % of broad money) in Armenia?
Give a very brief answer. 1.17. What is the difference between the highest and the second highest Claims(annual growth as % of broad money) of Bolivia?
Make the answer very short. 1.9. What is the difference between the highest and the second highest Claims(annual growth as % of broad money) of Czech Republic?
Your answer should be compact. 3.84. What is the difference between the highest and the second highest Claims(annual growth as % of broad money) of Venezuela?
Provide a succinct answer. 11.54. What is the difference between the highest and the lowest Claims(annual growth as % of broad money) of Armenia?
Keep it short and to the point. 27.41. What is the difference between the highest and the lowest Claims(annual growth as % of broad money) of Bolivia?
Your response must be concise. 7.81. What is the difference between the highest and the lowest Claims(annual growth as % of broad money) in Czech Republic?
Provide a short and direct response. 13.4. What is the difference between the highest and the lowest Claims(annual growth as % of broad money) of Venezuela?
Ensure brevity in your answer.  30.06. 